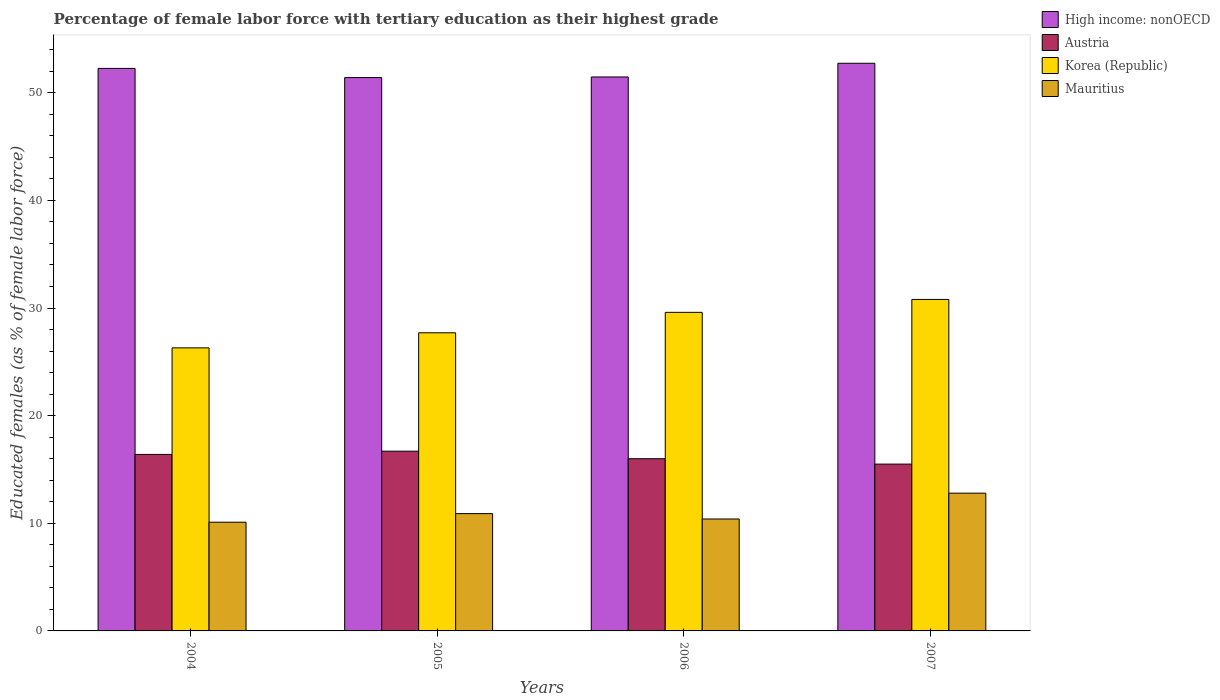How many groups of bars are there?
Your response must be concise. 4. Are the number of bars per tick equal to the number of legend labels?
Provide a succinct answer. Yes. How many bars are there on the 4th tick from the left?
Provide a short and direct response. 4. How many bars are there on the 3rd tick from the right?
Ensure brevity in your answer.  4. What is the percentage of female labor force with tertiary education in Korea (Republic) in 2006?
Give a very brief answer. 29.6. Across all years, what is the maximum percentage of female labor force with tertiary education in Mauritius?
Offer a very short reply. 12.8. What is the total percentage of female labor force with tertiary education in Austria in the graph?
Provide a short and direct response. 64.6. What is the difference between the percentage of female labor force with tertiary education in High income: nonOECD in 2004 and that in 2007?
Keep it short and to the point. -0.48. What is the difference between the percentage of female labor force with tertiary education in High income: nonOECD in 2007 and the percentage of female labor force with tertiary education in Korea (Republic) in 2004?
Offer a very short reply. 26.44. What is the average percentage of female labor force with tertiary education in Mauritius per year?
Provide a short and direct response. 11.05. In the year 2006, what is the difference between the percentage of female labor force with tertiary education in High income: nonOECD and percentage of female labor force with tertiary education in Austria?
Keep it short and to the point. 35.47. What is the ratio of the percentage of female labor force with tertiary education in Austria in 2004 to that in 2006?
Provide a short and direct response. 1.02. Is the percentage of female labor force with tertiary education in High income: nonOECD in 2004 less than that in 2007?
Give a very brief answer. Yes. Is the difference between the percentage of female labor force with tertiary education in High income: nonOECD in 2004 and 2007 greater than the difference between the percentage of female labor force with tertiary education in Austria in 2004 and 2007?
Your answer should be very brief. No. What is the difference between the highest and the second highest percentage of female labor force with tertiary education in Korea (Republic)?
Provide a short and direct response. 1.2. What is the difference between the highest and the lowest percentage of female labor force with tertiary education in Mauritius?
Provide a succinct answer. 2.7. Is it the case that in every year, the sum of the percentage of female labor force with tertiary education in Austria and percentage of female labor force with tertiary education in High income: nonOECD is greater than the sum of percentage of female labor force with tertiary education in Korea (Republic) and percentage of female labor force with tertiary education in Mauritius?
Ensure brevity in your answer.  Yes. What does the 1st bar from the left in 2007 represents?
Ensure brevity in your answer.  High income: nonOECD. Are all the bars in the graph horizontal?
Give a very brief answer. No. How many years are there in the graph?
Provide a short and direct response. 4. What is the difference between two consecutive major ticks on the Y-axis?
Provide a short and direct response. 10. Does the graph contain any zero values?
Your answer should be compact. No. How many legend labels are there?
Your response must be concise. 4. What is the title of the graph?
Give a very brief answer. Percentage of female labor force with tertiary education as their highest grade. What is the label or title of the Y-axis?
Offer a very short reply. Educated females (as % of female labor force). What is the Educated females (as % of female labor force) in High income: nonOECD in 2004?
Ensure brevity in your answer.  52.27. What is the Educated females (as % of female labor force) of Austria in 2004?
Your response must be concise. 16.4. What is the Educated females (as % of female labor force) in Korea (Republic) in 2004?
Offer a terse response. 26.3. What is the Educated females (as % of female labor force) in Mauritius in 2004?
Your response must be concise. 10.1. What is the Educated females (as % of female labor force) in High income: nonOECD in 2005?
Your answer should be compact. 51.41. What is the Educated females (as % of female labor force) of Austria in 2005?
Your response must be concise. 16.7. What is the Educated females (as % of female labor force) in Korea (Republic) in 2005?
Ensure brevity in your answer.  27.7. What is the Educated females (as % of female labor force) in Mauritius in 2005?
Ensure brevity in your answer.  10.9. What is the Educated females (as % of female labor force) in High income: nonOECD in 2006?
Your answer should be compact. 51.47. What is the Educated females (as % of female labor force) of Austria in 2006?
Your answer should be very brief. 16. What is the Educated females (as % of female labor force) in Korea (Republic) in 2006?
Your answer should be compact. 29.6. What is the Educated females (as % of female labor force) of Mauritius in 2006?
Keep it short and to the point. 10.4. What is the Educated females (as % of female labor force) in High income: nonOECD in 2007?
Your answer should be very brief. 52.74. What is the Educated females (as % of female labor force) in Austria in 2007?
Make the answer very short. 15.5. What is the Educated females (as % of female labor force) of Korea (Republic) in 2007?
Provide a short and direct response. 30.8. What is the Educated females (as % of female labor force) of Mauritius in 2007?
Your response must be concise. 12.8. Across all years, what is the maximum Educated females (as % of female labor force) of High income: nonOECD?
Your answer should be very brief. 52.74. Across all years, what is the maximum Educated females (as % of female labor force) in Austria?
Make the answer very short. 16.7. Across all years, what is the maximum Educated females (as % of female labor force) of Korea (Republic)?
Offer a very short reply. 30.8. Across all years, what is the maximum Educated females (as % of female labor force) of Mauritius?
Offer a terse response. 12.8. Across all years, what is the minimum Educated females (as % of female labor force) of High income: nonOECD?
Keep it short and to the point. 51.41. Across all years, what is the minimum Educated females (as % of female labor force) in Korea (Republic)?
Offer a very short reply. 26.3. Across all years, what is the minimum Educated females (as % of female labor force) in Mauritius?
Offer a terse response. 10.1. What is the total Educated females (as % of female labor force) of High income: nonOECD in the graph?
Ensure brevity in your answer.  207.89. What is the total Educated females (as % of female labor force) in Austria in the graph?
Give a very brief answer. 64.6. What is the total Educated females (as % of female labor force) of Korea (Republic) in the graph?
Give a very brief answer. 114.4. What is the total Educated females (as % of female labor force) of Mauritius in the graph?
Your answer should be compact. 44.2. What is the difference between the Educated females (as % of female labor force) of High income: nonOECD in 2004 and that in 2005?
Your answer should be very brief. 0.85. What is the difference between the Educated females (as % of female labor force) in Austria in 2004 and that in 2005?
Your answer should be compact. -0.3. What is the difference between the Educated females (as % of female labor force) in High income: nonOECD in 2004 and that in 2006?
Keep it short and to the point. 0.8. What is the difference between the Educated females (as % of female labor force) of Austria in 2004 and that in 2006?
Provide a short and direct response. 0.4. What is the difference between the Educated females (as % of female labor force) of Korea (Republic) in 2004 and that in 2006?
Your response must be concise. -3.3. What is the difference between the Educated females (as % of female labor force) in High income: nonOECD in 2004 and that in 2007?
Your answer should be compact. -0.48. What is the difference between the Educated females (as % of female labor force) in Austria in 2004 and that in 2007?
Make the answer very short. 0.9. What is the difference between the Educated females (as % of female labor force) in Mauritius in 2004 and that in 2007?
Offer a terse response. -2.7. What is the difference between the Educated females (as % of female labor force) of High income: nonOECD in 2005 and that in 2006?
Offer a very short reply. -0.06. What is the difference between the Educated females (as % of female labor force) in Korea (Republic) in 2005 and that in 2006?
Keep it short and to the point. -1.9. What is the difference between the Educated females (as % of female labor force) of Mauritius in 2005 and that in 2006?
Your answer should be very brief. 0.5. What is the difference between the Educated females (as % of female labor force) in High income: nonOECD in 2005 and that in 2007?
Your answer should be very brief. -1.33. What is the difference between the Educated females (as % of female labor force) in Austria in 2005 and that in 2007?
Give a very brief answer. 1.2. What is the difference between the Educated females (as % of female labor force) in Mauritius in 2005 and that in 2007?
Keep it short and to the point. -1.9. What is the difference between the Educated females (as % of female labor force) in High income: nonOECD in 2006 and that in 2007?
Offer a terse response. -1.27. What is the difference between the Educated females (as % of female labor force) of Mauritius in 2006 and that in 2007?
Give a very brief answer. -2.4. What is the difference between the Educated females (as % of female labor force) in High income: nonOECD in 2004 and the Educated females (as % of female labor force) in Austria in 2005?
Offer a terse response. 35.57. What is the difference between the Educated females (as % of female labor force) of High income: nonOECD in 2004 and the Educated females (as % of female labor force) of Korea (Republic) in 2005?
Your answer should be compact. 24.57. What is the difference between the Educated females (as % of female labor force) in High income: nonOECD in 2004 and the Educated females (as % of female labor force) in Mauritius in 2005?
Provide a short and direct response. 41.37. What is the difference between the Educated females (as % of female labor force) in Austria in 2004 and the Educated females (as % of female labor force) in Korea (Republic) in 2005?
Provide a succinct answer. -11.3. What is the difference between the Educated females (as % of female labor force) of High income: nonOECD in 2004 and the Educated females (as % of female labor force) of Austria in 2006?
Your answer should be compact. 36.27. What is the difference between the Educated females (as % of female labor force) of High income: nonOECD in 2004 and the Educated females (as % of female labor force) of Korea (Republic) in 2006?
Your answer should be compact. 22.67. What is the difference between the Educated females (as % of female labor force) in High income: nonOECD in 2004 and the Educated females (as % of female labor force) in Mauritius in 2006?
Keep it short and to the point. 41.87. What is the difference between the Educated females (as % of female labor force) of Austria in 2004 and the Educated females (as % of female labor force) of Korea (Republic) in 2006?
Offer a terse response. -13.2. What is the difference between the Educated females (as % of female labor force) in High income: nonOECD in 2004 and the Educated females (as % of female labor force) in Austria in 2007?
Provide a short and direct response. 36.77. What is the difference between the Educated females (as % of female labor force) of High income: nonOECD in 2004 and the Educated females (as % of female labor force) of Korea (Republic) in 2007?
Provide a succinct answer. 21.47. What is the difference between the Educated females (as % of female labor force) in High income: nonOECD in 2004 and the Educated females (as % of female labor force) in Mauritius in 2007?
Offer a terse response. 39.47. What is the difference between the Educated females (as % of female labor force) in Austria in 2004 and the Educated females (as % of female labor force) in Korea (Republic) in 2007?
Ensure brevity in your answer.  -14.4. What is the difference between the Educated females (as % of female labor force) of Korea (Republic) in 2004 and the Educated females (as % of female labor force) of Mauritius in 2007?
Your answer should be very brief. 13.5. What is the difference between the Educated females (as % of female labor force) in High income: nonOECD in 2005 and the Educated females (as % of female labor force) in Austria in 2006?
Give a very brief answer. 35.41. What is the difference between the Educated females (as % of female labor force) in High income: nonOECD in 2005 and the Educated females (as % of female labor force) in Korea (Republic) in 2006?
Make the answer very short. 21.81. What is the difference between the Educated females (as % of female labor force) of High income: nonOECD in 2005 and the Educated females (as % of female labor force) of Mauritius in 2006?
Keep it short and to the point. 41.01. What is the difference between the Educated females (as % of female labor force) of Austria in 2005 and the Educated females (as % of female labor force) of Korea (Republic) in 2006?
Your answer should be compact. -12.9. What is the difference between the Educated females (as % of female labor force) in Austria in 2005 and the Educated females (as % of female labor force) in Mauritius in 2006?
Give a very brief answer. 6.3. What is the difference between the Educated females (as % of female labor force) of High income: nonOECD in 2005 and the Educated females (as % of female labor force) of Austria in 2007?
Your answer should be very brief. 35.91. What is the difference between the Educated females (as % of female labor force) of High income: nonOECD in 2005 and the Educated females (as % of female labor force) of Korea (Republic) in 2007?
Your answer should be very brief. 20.61. What is the difference between the Educated females (as % of female labor force) in High income: nonOECD in 2005 and the Educated females (as % of female labor force) in Mauritius in 2007?
Give a very brief answer. 38.61. What is the difference between the Educated females (as % of female labor force) in Austria in 2005 and the Educated females (as % of female labor force) in Korea (Republic) in 2007?
Your answer should be compact. -14.1. What is the difference between the Educated females (as % of female labor force) in High income: nonOECD in 2006 and the Educated females (as % of female labor force) in Austria in 2007?
Provide a succinct answer. 35.97. What is the difference between the Educated females (as % of female labor force) in High income: nonOECD in 2006 and the Educated females (as % of female labor force) in Korea (Republic) in 2007?
Your answer should be very brief. 20.67. What is the difference between the Educated females (as % of female labor force) of High income: nonOECD in 2006 and the Educated females (as % of female labor force) of Mauritius in 2007?
Your answer should be compact. 38.67. What is the difference between the Educated females (as % of female labor force) in Austria in 2006 and the Educated females (as % of female labor force) in Korea (Republic) in 2007?
Provide a succinct answer. -14.8. What is the average Educated females (as % of female labor force) in High income: nonOECD per year?
Your answer should be compact. 51.97. What is the average Educated females (as % of female labor force) of Austria per year?
Provide a succinct answer. 16.15. What is the average Educated females (as % of female labor force) in Korea (Republic) per year?
Make the answer very short. 28.6. What is the average Educated females (as % of female labor force) in Mauritius per year?
Provide a short and direct response. 11.05. In the year 2004, what is the difference between the Educated females (as % of female labor force) of High income: nonOECD and Educated females (as % of female labor force) of Austria?
Make the answer very short. 35.87. In the year 2004, what is the difference between the Educated females (as % of female labor force) in High income: nonOECD and Educated females (as % of female labor force) in Korea (Republic)?
Ensure brevity in your answer.  25.97. In the year 2004, what is the difference between the Educated females (as % of female labor force) of High income: nonOECD and Educated females (as % of female labor force) of Mauritius?
Offer a very short reply. 42.17. In the year 2004, what is the difference between the Educated females (as % of female labor force) in Austria and Educated females (as % of female labor force) in Mauritius?
Your answer should be very brief. 6.3. In the year 2004, what is the difference between the Educated females (as % of female labor force) in Korea (Republic) and Educated females (as % of female labor force) in Mauritius?
Provide a succinct answer. 16.2. In the year 2005, what is the difference between the Educated females (as % of female labor force) in High income: nonOECD and Educated females (as % of female labor force) in Austria?
Make the answer very short. 34.71. In the year 2005, what is the difference between the Educated females (as % of female labor force) in High income: nonOECD and Educated females (as % of female labor force) in Korea (Republic)?
Make the answer very short. 23.71. In the year 2005, what is the difference between the Educated females (as % of female labor force) in High income: nonOECD and Educated females (as % of female labor force) in Mauritius?
Your answer should be very brief. 40.51. In the year 2005, what is the difference between the Educated females (as % of female labor force) in Korea (Republic) and Educated females (as % of female labor force) in Mauritius?
Your answer should be very brief. 16.8. In the year 2006, what is the difference between the Educated females (as % of female labor force) of High income: nonOECD and Educated females (as % of female labor force) of Austria?
Provide a short and direct response. 35.47. In the year 2006, what is the difference between the Educated females (as % of female labor force) of High income: nonOECD and Educated females (as % of female labor force) of Korea (Republic)?
Provide a short and direct response. 21.87. In the year 2006, what is the difference between the Educated females (as % of female labor force) of High income: nonOECD and Educated females (as % of female labor force) of Mauritius?
Offer a terse response. 41.07. In the year 2006, what is the difference between the Educated females (as % of female labor force) in Austria and Educated females (as % of female labor force) in Korea (Republic)?
Your answer should be very brief. -13.6. In the year 2007, what is the difference between the Educated females (as % of female labor force) in High income: nonOECD and Educated females (as % of female labor force) in Austria?
Your answer should be very brief. 37.24. In the year 2007, what is the difference between the Educated females (as % of female labor force) in High income: nonOECD and Educated females (as % of female labor force) in Korea (Republic)?
Offer a very short reply. 21.94. In the year 2007, what is the difference between the Educated females (as % of female labor force) of High income: nonOECD and Educated females (as % of female labor force) of Mauritius?
Your answer should be compact. 39.94. In the year 2007, what is the difference between the Educated females (as % of female labor force) in Austria and Educated females (as % of female labor force) in Korea (Republic)?
Offer a terse response. -15.3. What is the ratio of the Educated females (as % of female labor force) of High income: nonOECD in 2004 to that in 2005?
Offer a very short reply. 1.02. What is the ratio of the Educated females (as % of female labor force) in Korea (Republic) in 2004 to that in 2005?
Your answer should be compact. 0.95. What is the ratio of the Educated females (as % of female labor force) in Mauritius in 2004 to that in 2005?
Make the answer very short. 0.93. What is the ratio of the Educated females (as % of female labor force) in High income: nonOECD in 2004 to that in 2006?
Your answer should be very brief. 1.02. What is the ratio of the Educated females (as % of female labor force) in Korea (Republic) in 2004 to that in 2006?
Your response must be concise. 0.89. What is the ratio of the Educated females (as % of female labor force) of Mauritius in 2004 to that in 2006?
Provide a succinct answer. 0.97. What is the ratio of the Educated females (as % of female labor force) in High income: nonOECD in 2004 to that in 2007?
Offer a very short reply. 0.99. What is the ratio of the Educated females (as % of female labor force) of Austria in 2004 to that in 2007?
Offer a very short reply. 1.06. What is the ratio of the Educated females (as % of female labor force) in Korea (Republic) in 2004 to that in 2007?
Your response must be concise. 0.85. What is the ratio of the Educated females (as % of female labor force) of Mauritius in 2004 to that in 2007?
Give a very brief answer. 0.79. What is the ratio of the Educated females (as % of female labor force) in High income: nonOECD in 2005 to that in 2006?
Provide a succinct answer. 1. What is the ratio of the Educated females (as % of female labor force) in Austria in 2005 to that in 2006?
Ensure brevity in your answer.  1.04. What is the ratio of the Educated females (as % of female labor force) of Korea (Republic) in 2005 to that in 2006?
Ensure brevity in your answer.  0.94. What is the ratio of the Educated females (as % of female labor force) of Mauritius in 2005 to that in 2006?
Your response must be concise. 1.05. What is the ratio of the Educated females (as % of female labor force) of High income: nonOECD in 2005 to that in 2007?
Your answer should be compact. 0.97. What is the ratio of the Educated females (as % of female labor force) in Austria in 2005 to that in 2007?
Offer a terse response. 1.08. What is the ratio of the Educated females (as % of female labor force) of Korea (Republic) in 2005 to that in 2007?
Your answer should be very brief. 0.9. What is the ratio of the Educated females (as % of female labor force) in Mauritius in 2005 to that in 2007?
Keep it short and to the point. 0.85. What is the ratio of the Educated females (as % of female labor force) of High income: nonOECD in 2006 to that in 2007?
Provide a short and direct response. 0.98. What is the ratio of the Educated females (as % of female labor force) of Austria in 2006 to that in 2007?
Your answer should be very brief. 1.03. What is the ratio of the Educated females (as % of female labor force) of Korea (Republic) in 2006 to that in 2007?
Offer a terse response. 0.96. What is the ratio of the Educated females (as % of female labor force) of Mauritius in 2006 to that in 2007?
Keep it short and to the point. 0.81. What is the difference between the highest and the second highest Educated females (as % of female labor force) of High income: nonOECD?
Provide a short and direct response. 0.48. What is the difference between the highest and the second highest Educated females (as % of female labor force) of Korea (Republic)?
Ensure brevity in your answer.  1.2. What is the difference between the highest and the lowest Educated females (as % of female labor force) in High income: nonOECD?
Offer a terse response. 1.33. What is the difference between the highest and the lowest Educated females (as % of female labor force) in Korea (Republic)?
Your answer should be compact. 4.5. What is the difference between the highest and the lowest Educated females (as % of female labor force) of Mauritius?
Your response must be concise. 2.7. 